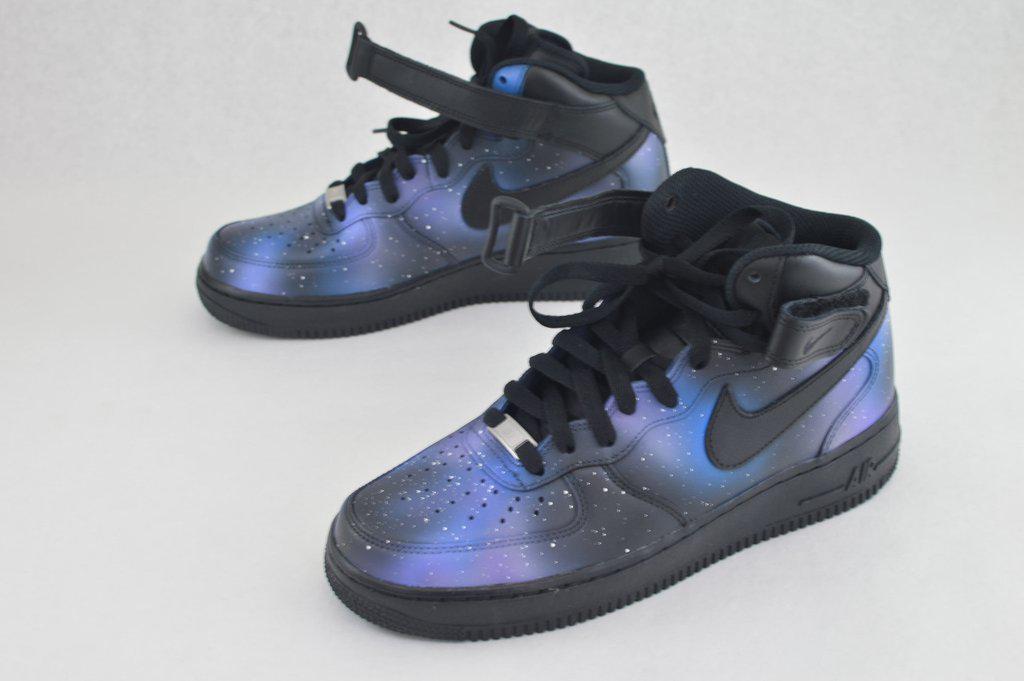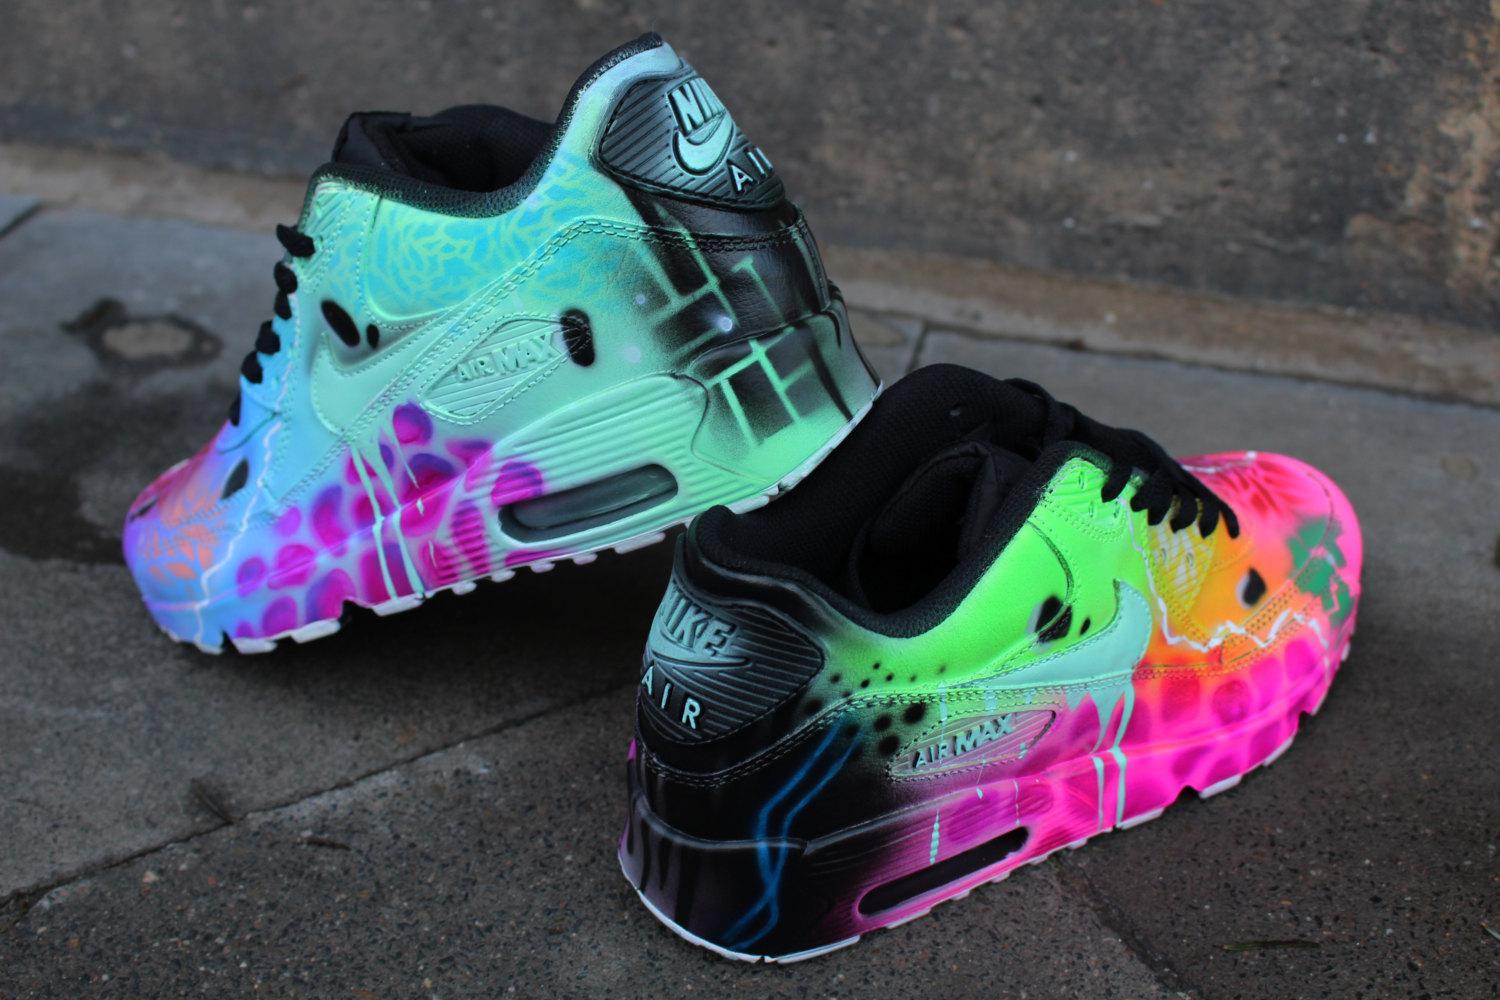The first image is the image on the left, the second image is the image on the right. Given the left and right images, does the statement "One pair of casual shoes has a small black tag sticking up from the back of each shoe." hold true? Answer yes or no. No. 